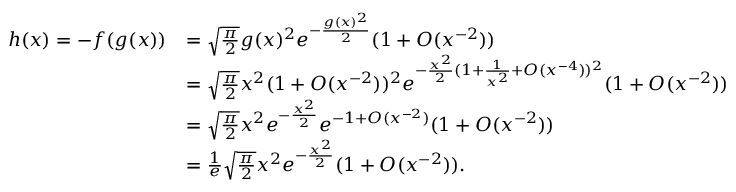<formula> <loc_0><loc_0><loc_500><loc_500>\begin{array} { r l } { h ( x ) = - f ( g ( x ) ) } & { = \sqrt { \frac { \pi } { 2 } } g ( x ) ^ { 2 } e ^ { - \frac { g ( x ) ^ { 2 } } { 2 } } ( 1 + O ( x ^ { - 2 } ) ) } \\ & { = \sqrt { \frac { \pi } { 2 } } x ^ { 2 } ( 1 + O ( x ^ { - 2 } ) ) ^ { 2 } e ^ { - \frac { x ^ { 2 } } { 2 } ( 1 + \frac { 1 } { x ^ { 2 } } + O ( x ^ { - 4 } ) ) ^ { 2 } } ( 1 + O ( x ^ { - 2 } ) ) } \\ & { = \sqrt { \frac { \pi } { 2 } } x ^ { 2 } e ^ { - \frac { x ^ { 2 } } { 2 } } e ^ { - 1 + O ( x ^ { - 2 } ) } ( 1 + O ( x ^ { - 2 } ) ) } \\ & { = \frac { 1 } e } \sqrt { \frac { \pi } { 2 } } x ^ { 2 } e ^ { - \frac { x ^ { 2 } } { 2 } } ( 1 + O ( x ^ { - 2 } ) ) . } \end{array}</formula> 